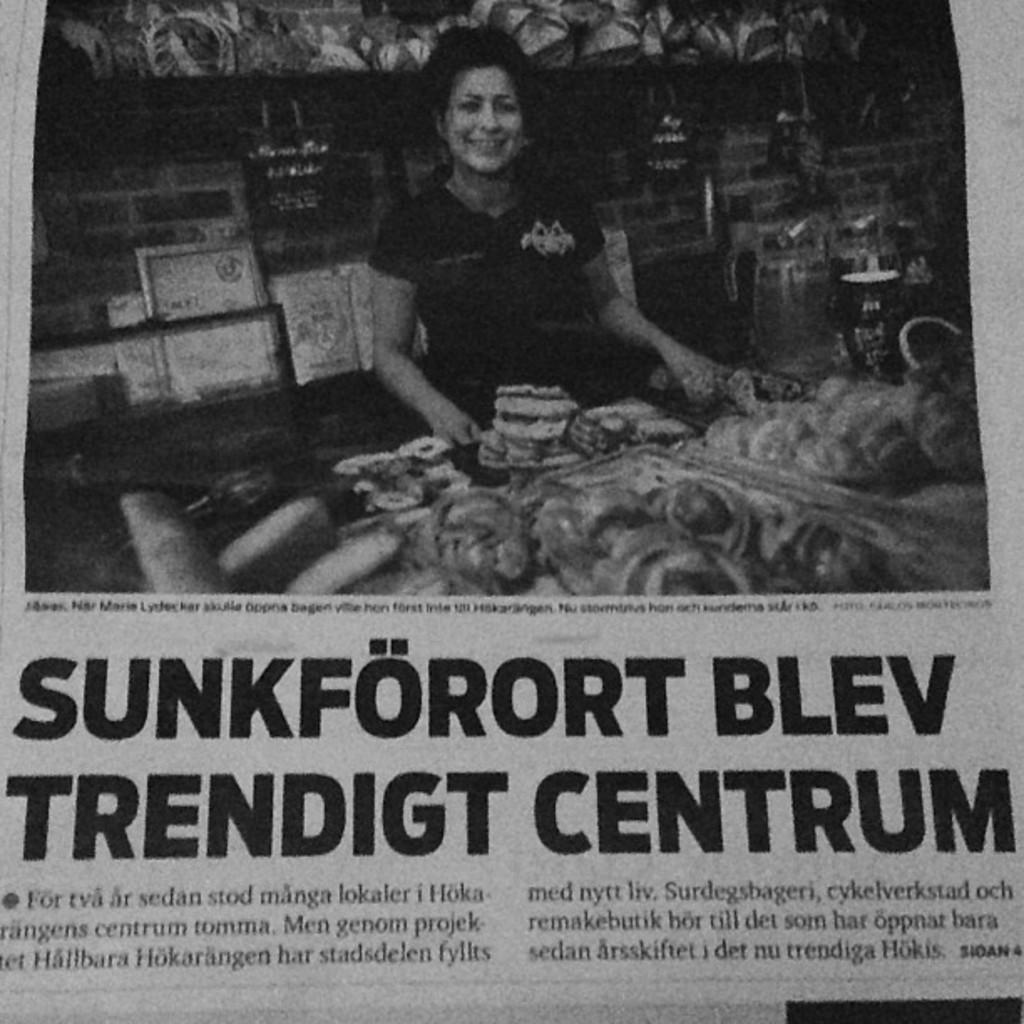<image>
Create a compact narrative representing the image presented. A newspaper article with the headline Sunkförort Blev Trendigt Centrum. 